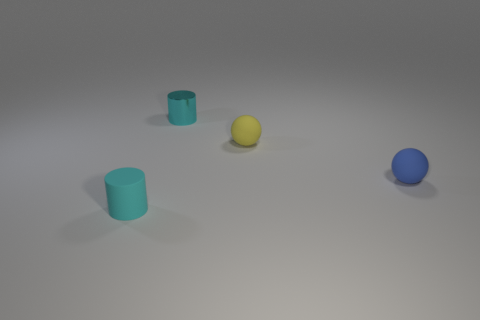There is a tiny metallic object; is it the same color as the object that is left of the small cyan metal object?
Your answer should be compact. Yes. What color is the other small thing that is the same shape as the cyan rubber object?
Your response must be concise. Cyan. Does the tiny yellow thing have the same material as the tiny ball in front of the yellow rubber ball?
Provide a short and direct response. Yes. What color is the tiny rubber cylinder?
Your answer should be compact. Cyan. The tiny cylinder behind the tiny thing on the left side of the tiny thing that is behind the tiny yellow matte ball is what color?
Make the answer very short. Cyan. Is the shape of the tiny yellow thing the same as the blue matte thing on the right side of the cyan metallic cylinder?
Offer a terse response. Yes. What color is the object that is in front of the tiny cyan shiny cylinder and left of the yellow ball?
Your response must be concise. Cyan. Are there any yellow objects that have the same shape as the blue thing?
Make the answer very short. Yes. Do the tiny metallic thing and the tiny matte cylinder have the same color?
Make the answer very short. Yes. Is there a small cyan cylinder that is to the right of the tiny cylinder that is in front of the yellow rubber object?
Offer a very short reply. Yes. 